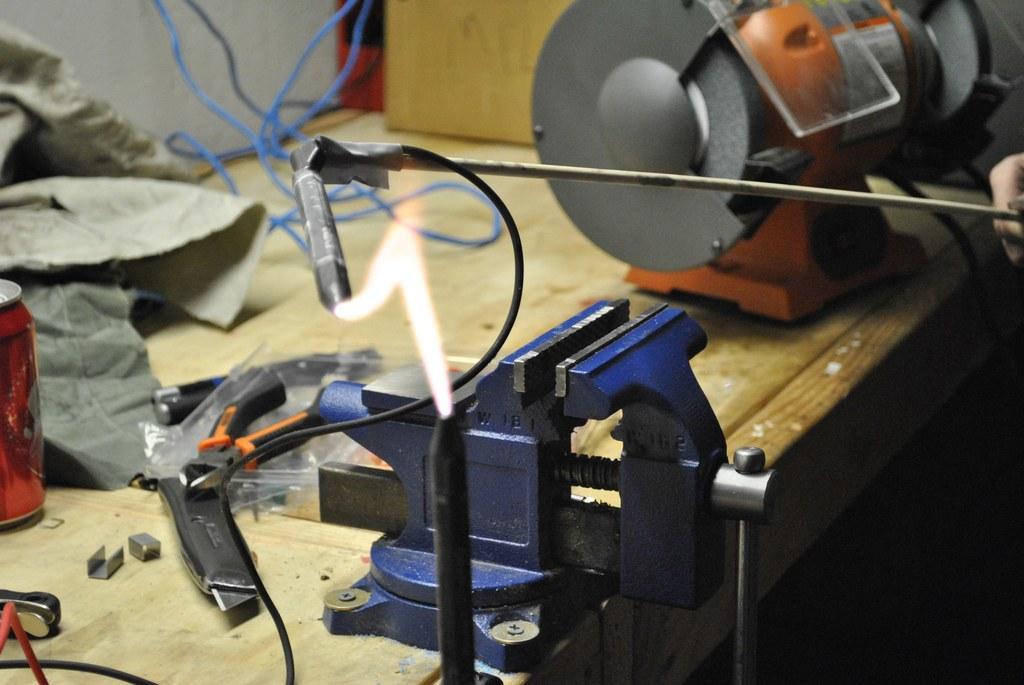Please provide a concise description of this image. In this picture I can see couple of machines, few instruments and a can on the table and I can see a human hand holding a metal rod and I can see fire. 